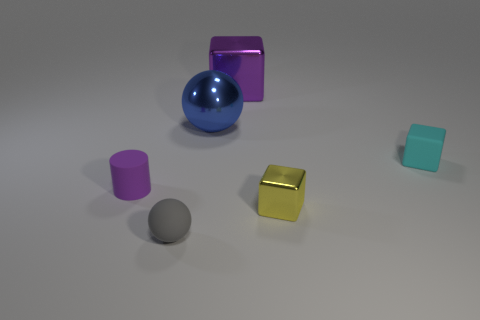Could you invent a story based on the arrangement of these objects? In a tranquil corner of an alternative universe, the color guardians each have an object that holds their essence. The large metallic block, with its lustrous surface, guards the portal to reflection, where one can see their true self. The blue sphere is the orb of tranquility, radiating calmness to those who gaze upon it. The vibrant cylinders are the pillars of creativity, inspiring innovation in all directions, while the small cube is the cornerstone of wisdom, grounding the abstract entities with its solidity and earthy hue. Together, they maintain the balance of vibrancy and peace in their otherworldy realm. 